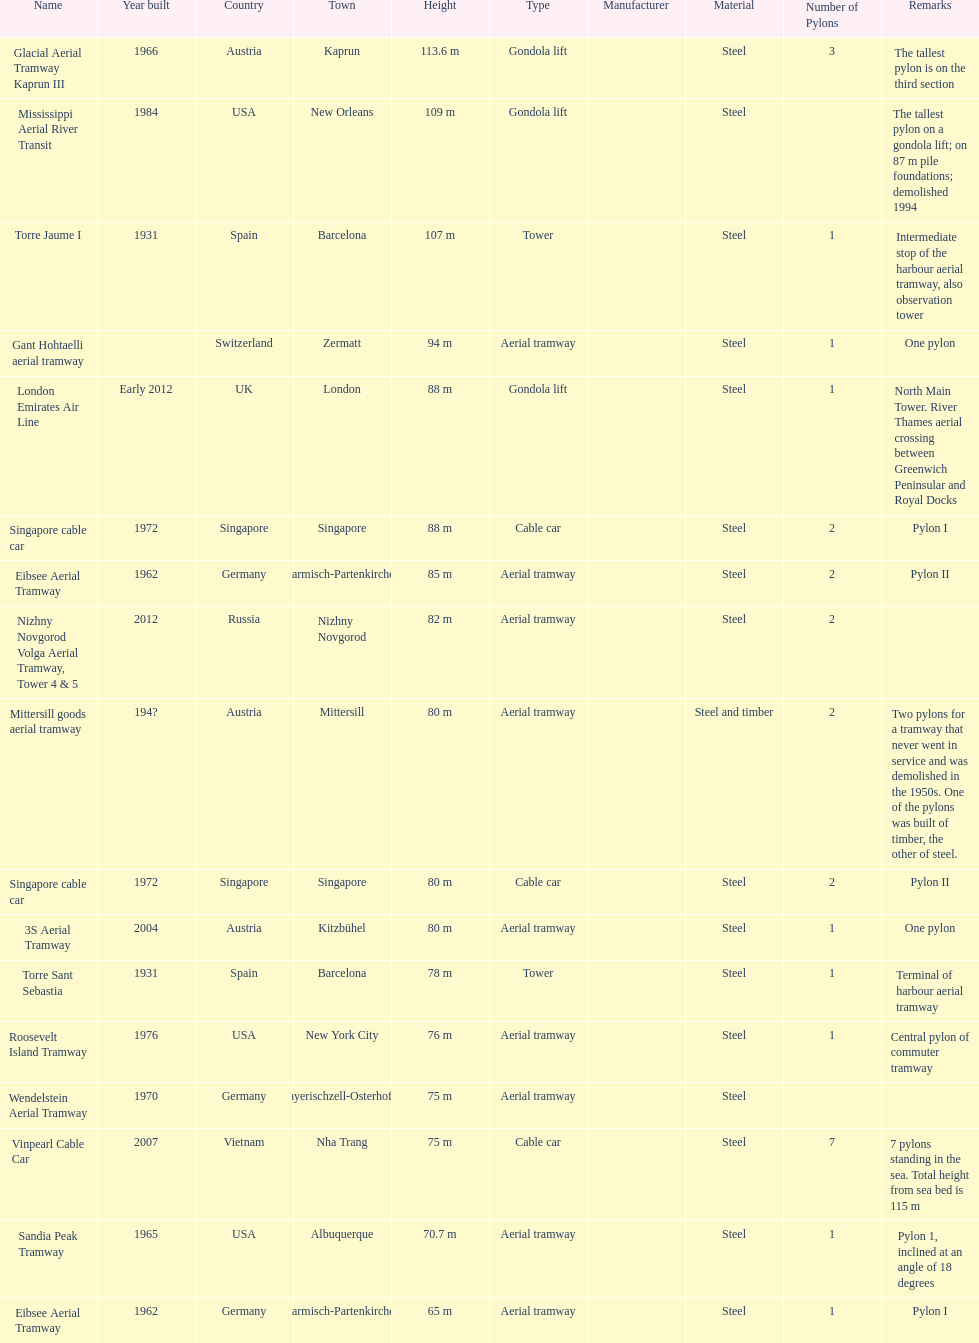How many metres is the tallest pylon? 113.6 m. 